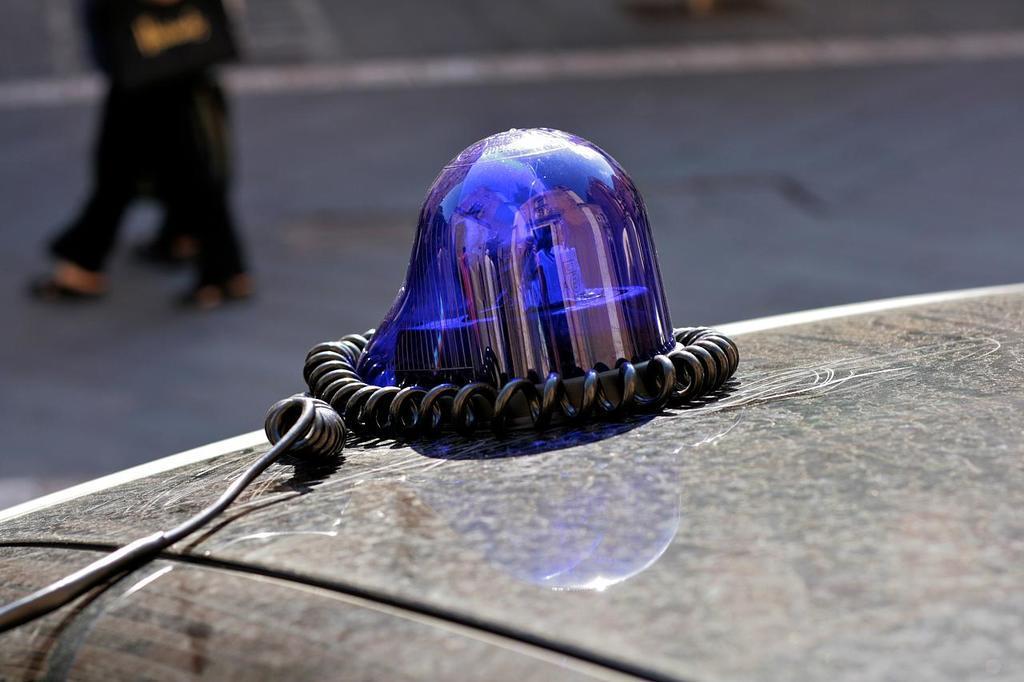Could you give a brief overview of what you see in this image? This is a revolving light bulb with a wire, which is fixed at the top of the vehicle. In the background, I can see a person walking. 